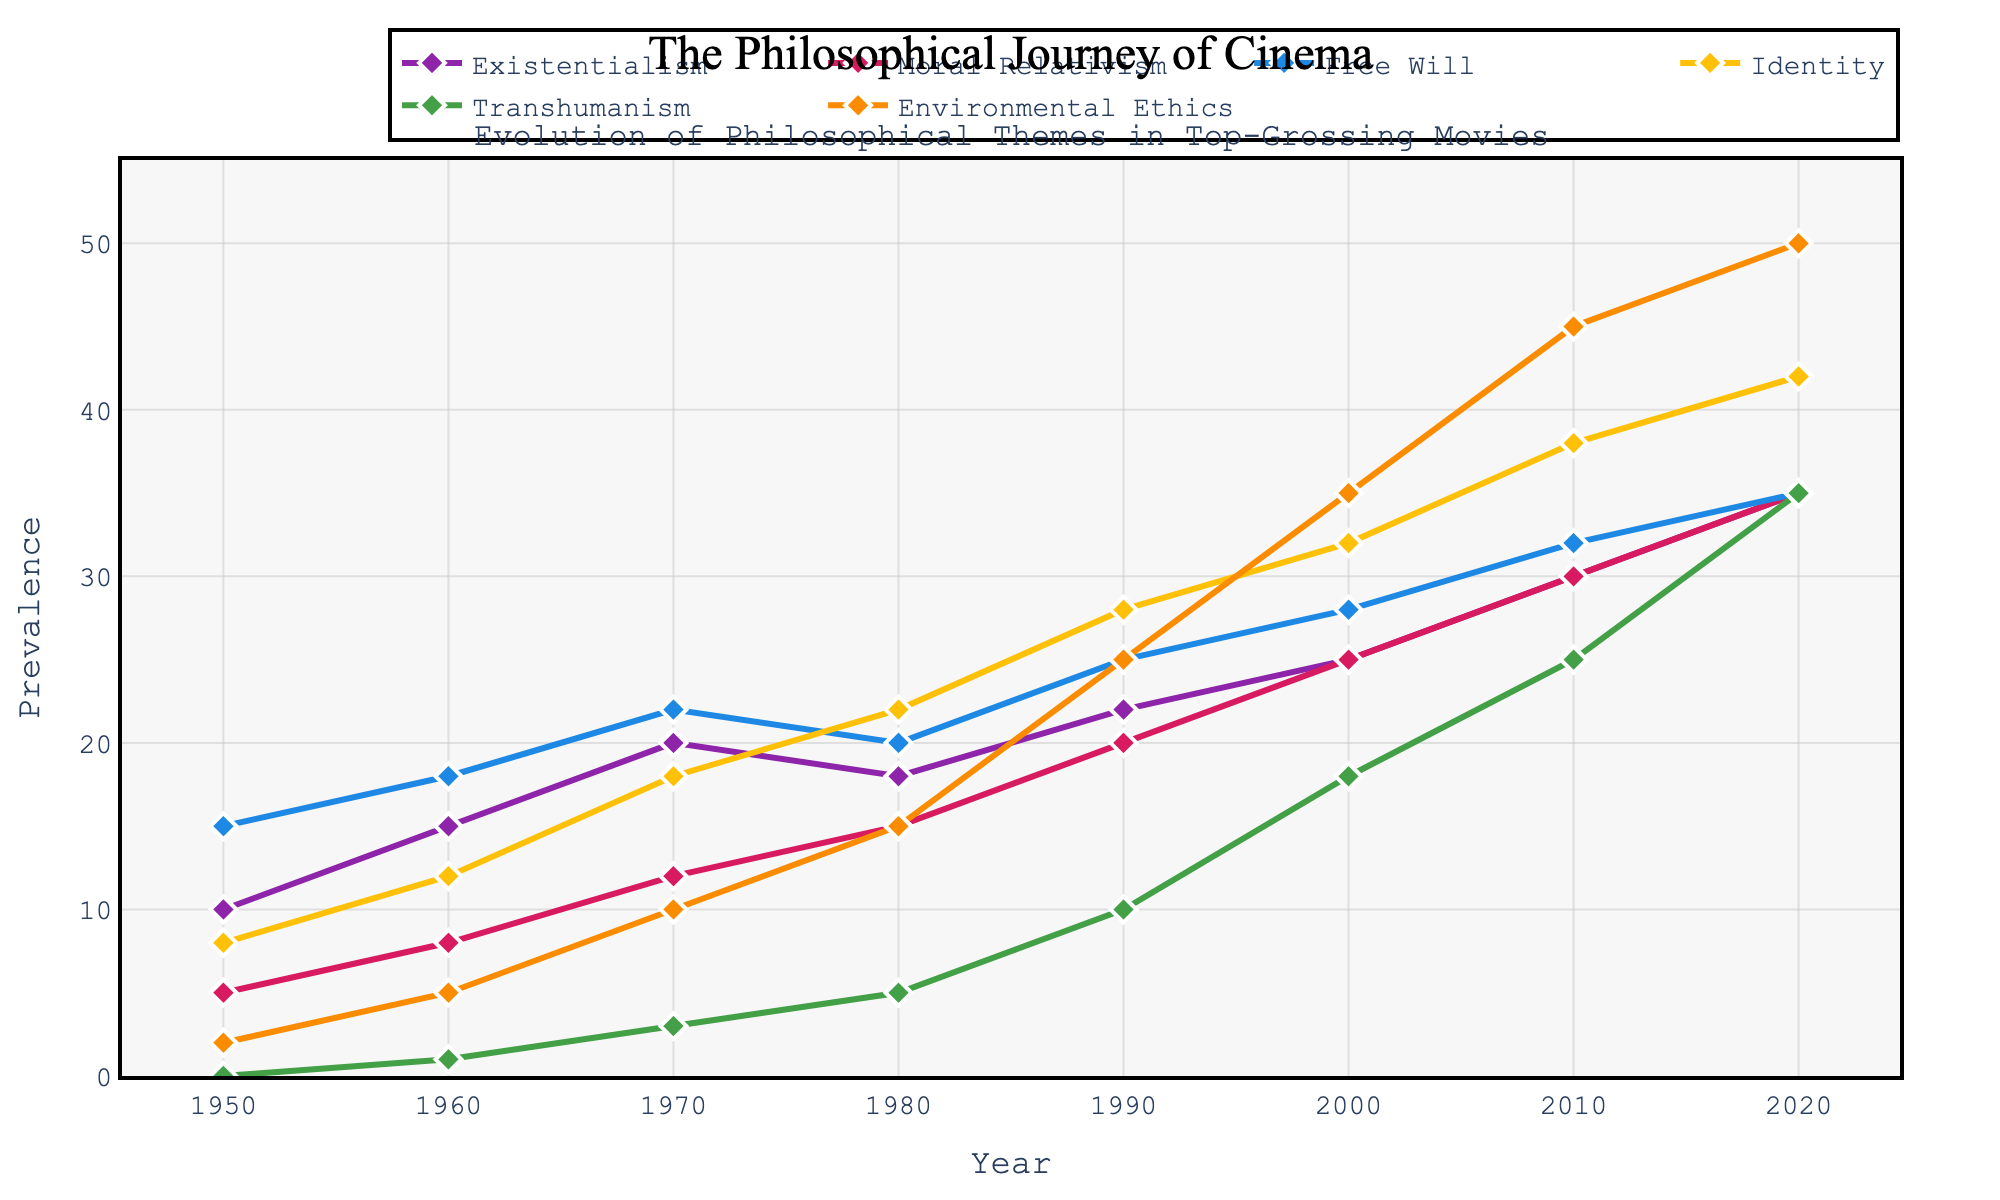what's the trend of Environmental Ethics from 1950 to 2020? Plotting the Environmental Ethics line, we observe a consistent upward trend from 2 in 1950 to 50 in 2020
Answer: Upward trend which philosophical theme showed the steepest increase in prevalence from 1990 to 2020? By comparing the differences, Existentialism increased by 13 (35-22), Moral Relativism by 15 (35-20), Free Will by 10 (35-25), Identity by 14 (42-28), Transhumanism by 25 (35-10), and Environmental Ethics by 25 (50-25). Transhumanism and Environmental Ethics both showed the steepest increase.
Answer: Transhumanism and Environmental Ethics how does the prevalence of Existentialism in 1980 compare to the prevalence of Identity in 1980? Referencing 1980, Existentialism's value is 18 while Identity's is 22.
Answer: Identity is higher what is the average prevalence of Free Will over the entire period? Summing Free Will values and dividing by the number of years: (15+18+22+20+25+28+32+35)/8 = 195/8 = 24.375
Answer: 24.375 in which decade did Moral Relativism first surpass 20 in prevalence? Examining Moral Relativism values, it first surpasses 20 in 1990 (value 20 in 1990)
Answer: 1990s which theme reached its midpoint between 1950 and 2020 the fastest? Comparing trends, Free Will reaches 17.5 (half of 35) in the 1970s, Identity reaches 21 (half of 42) by 1980, Transhumanism halfway (17.5) by around 2000. Free Will hits its midpoint earliest.
Answer: Free Will which philosophical theme had the smallest change in prevalence from 1980 to 1990? Checking differences, Existentialism changes by 4 (22-18), Moral Relativism by 5 (20-15), Free Will by 5 (25-20), Identity by 6 (28-22), Transhumanism by 5 (10-5), Environmental Ethics by 10 (25-15). The smallest change is shared between Moral Relativism, Free Will, and Transhumanism.
Answer: Moral Relativism, Free Will, and Transhumanism how does the prevalence of philosophical themes in the 1970s compare to the 2000s? Summing 1970s values: (20+12+22+18+3+10)=85. Summing 2000s values: (25+25+28+32+18+35)=163. So 1970s have lower prevalence compared to 2000s.
Answer: Lower in the 1970s what is the combined prevalence of Identity and Environmental Ethics in 2020? Adding Identity (42) and Environmental Ethics (50) in 2020: 42+50 = 92
Answer: 92 